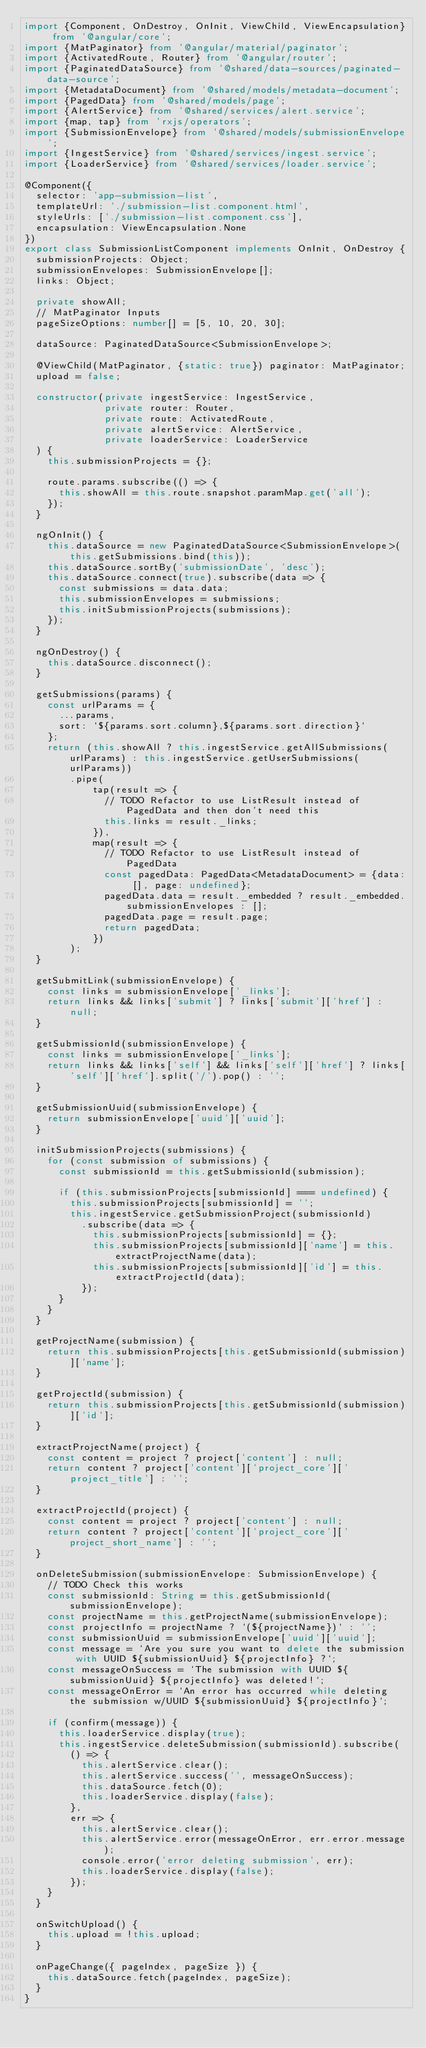Convert code to text. <code><loc_0><loc_0><loc_500><loc_500><_TypeScript_>import {Component, OnDestroy, OnInit, ViewChild, ViewEncapsulation} from '@angular/core';
import {MatPaginator} from '@angular/material/paginator';
import {ActivatedRoute, Router} from '@angular/router';
import {PaginatedDataSource} from '@shared/data-sources/paginated-data-source';
import {MetadataDocument} from '@shared/models/metadata-document';
import {PagedData} from '@shared/models/page';
import {AlertService} from '@shared/services/alert.service';
import {map, tap} from 'rxjs/operators';
import {SubmissionEnvelope} from '@shared/models/submissionEnvelope';
import {IngestService} from '@shared/services/ingest.service';
import {LoaderService} from '@shared/services/loader.service';

@Component({
  selector: 'app-submission-list',
  templateUrl: './submission-list.component.html',
  styleUrls: ['./submission-list.component.css'],
  encapsulation: ViewEncapsulation.None
})
export class SubmissionListComponent implements OnInit, OnDestroy {
  submissionProjects: Object;
  submissionEnvelopes: SubmissionEnvelope[];
  links: Object;

  private showAll;
  // MatPaginator Inputs
  pageSizeOptions: number[] = [5, 10, 20, 30];

  dataSource: PaginatedDataSource<SubmissionEnvelope>;

  @ViewChild(MatPaginator, {static: true}) paginator: MatPaginator;
  upload = false;

  constructor(private ingestService: IngestService,
              private router: Router,
              private route: ActivatedRoute,
              private alertService: AlertService,
              private loaderService: LoaderService
  ) {
    this.submissionProjects = {};

    route.params.subscribe(() => {
      this.showAll = this.route.snapshot.paramMap.get('all');
    });
  }

  ngOnInit() {
    this.dataSource = new PaginatedDataSource<SubmissionEnvelope>(this.getSubmissions.bind(this));
    this.dataSource.sortBy('submissionDate', 'desc');
    this.dataSource.connect(true).subscribe(data => {
      const submissions = data.data;
      this.submissionEnvelopes = submissions;
      this.initSubmissionProjects(submissions);
    });
  }

  ngOnDestroy() {
    this.dataSource.disconnect();
  }

  getSubmissions(params) {
    const urlParams = {
      ...params,
      sort: `${params.sort.column},${params.sort.direction}`
    };
    return (this.showAll ? this.ingestService.getAllSubmissions(urlParams) : this.ingestService.getUserSubmissions(urlParams))
        .pipe(
            tap(result => {
              // TODO Refactor to use ListResult instead of PagedData and then don't need this
              this.links = result._links;
            }),
            map(result => {
              // TODO Refactor to use ListResult instead of PagedData
              const pagedData: PagedData<MetadataDocument> = {data: [], page: undefined};
              pagedData.data = result._embedded ? result._embedded.submissionEnvelopes : [];
              pagedData.page = result.page;
              return pagedData;
            })
        );
  }

  getSubmitLink(submissionEnvelope) {
    const links = submissionEnvelope['_links'];
    return links && links['submit'] ? links['submit']['href'] : null;
  }

  getSubmissionId(submissionEnvelope) {
    const links = submissionEnvelope['_links'];
    return links && links['self'] && links['self']['href'] ? links['self']['href'].split('/').pop() : '';
  }

  getSubmissionUuid(submissionEnvelope) {
    return submissionEnvelope['uuid']['uuid'];
  }

  initSubmissionProjects(submissions) {
    for (const submission of submissions) {
      const submissionId = this.getSubmissionId(submission);

      if (this.submissionProjects[submissionId] === undefined) {
        this.submissionProjects[submissionId] = '';
        this.ingestService.getSubmissionProject(submissionId)
          .subscribe(data => {
            this.submissionProjects[submissionId] = {};
            this.submissionProjects[submissionId]['name'] = this.extractProjectName(data);
            this.submissionProjects[submissionId]['id'] = this.extractProjectId(data);
          });
      }
    }
  }

  getProjectName(submission) {
    return this.submissionProjects[this.getSubmissionId(submission)]['name'];
  }

  getProjectId(submission) {
    return this.submissionProjects[this.getSubmissionId(submission)]['id'];
  }

  extractProjectName(project) {
    const content = project ? project['content'] : null;
    return content ? project['content']['project_core']['project_title'] : '';
  }

  extractProjectId(project) {
    const content = project ? project['content'] : null;
    return content ? project['content']['project_core']['project_short_name'] : '';
  }

  onDeleteSubmission(submissionEnvelope: SubmissionEnvelope) {
    // TODO Check this works
    const submissionId: String = this.getSubmissionId(submissionEnvelope);
    const projectName = this.getProjectName(submissionEnvelope);
    const projectInfo = projectName ? `(${projectName})` : '';
    const submissionUuid = submissionEnvelope['uuid']['uuid'];
    const message = `Are you sure you want to delete the submission with UUID ${submissionUuid} ${projectInfo} ?`;
    const messageOnSuccess = `The submission with UUID ${submissionUuid} ${projectInfo} was deleted!`;
    const messageOnError = `An error has occurred while deleting the submission w/UUID ${submissionUuid} ${projectInfo}`;

    if (confirm(message)) {
      this.loaderService.display(true);
      this.ingestService.deleteSubmission(submissionId).subscribe(
        () => {
          this.alertService.clear();
          this.alertService.success('', messageOnSuccess);
          this.dataSource.fetch(0);
          this.loaderService.display(false);
        },
        err => {
          this.alertService.clear();
          this.alertService.error(messageOnError, err.error.message);
          console.error('error deleting submission', err);
          this.loaderService.display(false);
        });
    }
  }

  onSwitchUpload() {
    this.upload = !this.upload;
  }

  onPageChange({ pageIndex, pageSize }) {
    this.dataSource.fetch(pageIndex, pageSize);
  }
}


</code> 